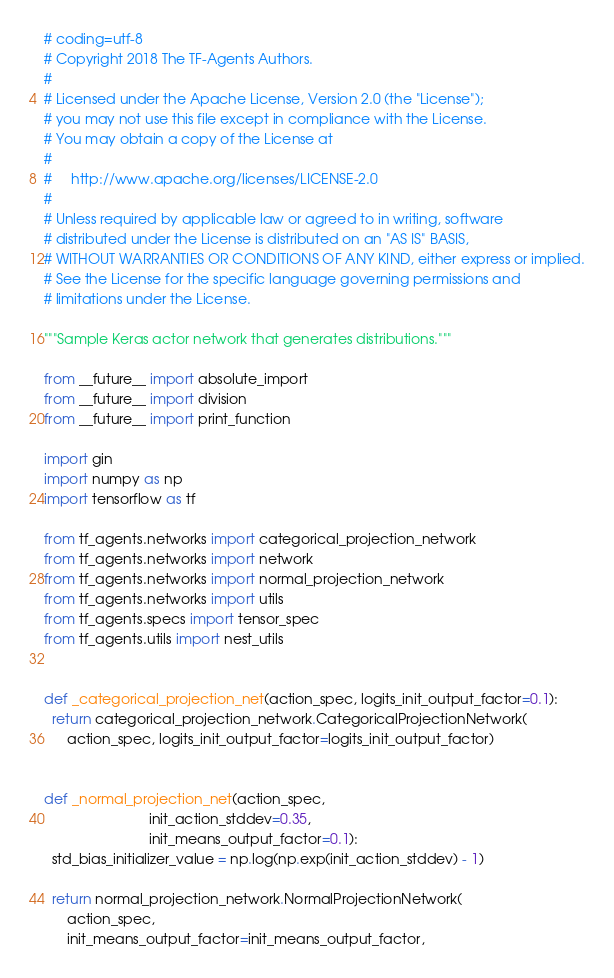<code> <loc_0><loc_0><loc_500><loc_500><_Python_># coding=utf-8
# Copyright 2018 The TF-Agents Authors.
#
# Licensed under the Apache License, Version 2.0 (the "License");
# you may not use this file except in compliance with the License.
# You may obtain a copy of the License at
#
#     http://www.apache.org/licenses/LICENSE-2.0
#
# Unless required by applicable law or agreed to in writing, software
# distributed under the License is distributed on an "AS IS" BASIS,
# WITHOUT WARRANTIES OR CONDITIONS OF ANY KIND, either express or implied.
# See the License for the specific language governing permissions and
# limitations under the License.

"""Sample Keras actor network that generates distributions."""

from __future__ import absolute_import
from __future__ import division
from __future__ import print_function

import gin
import numpy as np
import tensorflow as tf

from tf_agents.networks import categorical_projection_network
from tf_agents.networks import network
from tf_agents.networks import normal_projection_network
from tf_agents.networks import utils
from tf_agents.specs import tensor_spec
from tf_agents.utils import nest_utils


def _categorical_projection_net(action_spec, logits_init_output_factor=0.1):
  return categorical_projection_network.CategoricalProjectionNetwork(
      action_spec, logits_init_output_factor=logits_init_output_factor)


def _normal_projection_net(action_spec,
                           init_action_stddev=0.35,
                           init_means_output_factor=0.1):
  std_bias_initializer_value = np.log(np.exp(init_action_stddev) - 1)

  return normal_projection_network.NormalProjectionNetwork(
      action_spec,
      init_means_output_factor=init_means_output_factor,</code> 